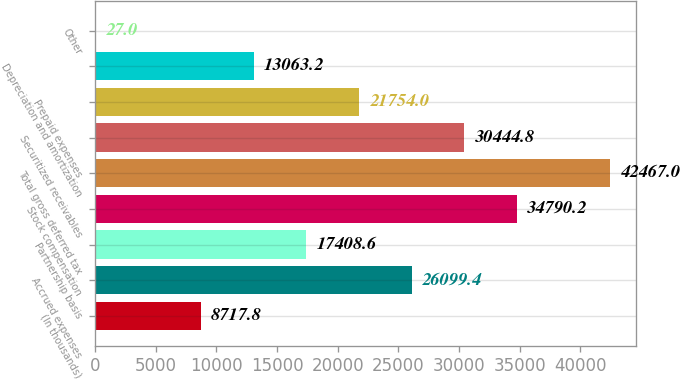<chart> <loc_0><loc_0><loc_500><loc_500><bar_chart><fcel>(In thousands)<fcel>Accrued expenses<fcel>Partnership basis<fcel>Stock compensation<fcel>Total gross deferred tax<fcel>Securitized receivables<fcel>Prepaid expenses<fcel>Depreciation and amortization<fcel>Other<nl><fcel>8717.8<fcel>26099.4<fcel>17408.6<fcel>34790.2<fcel>42467<fcel>30444.8<fcel>21754<fcel>13063.2<fcel>27<nl></chart> 